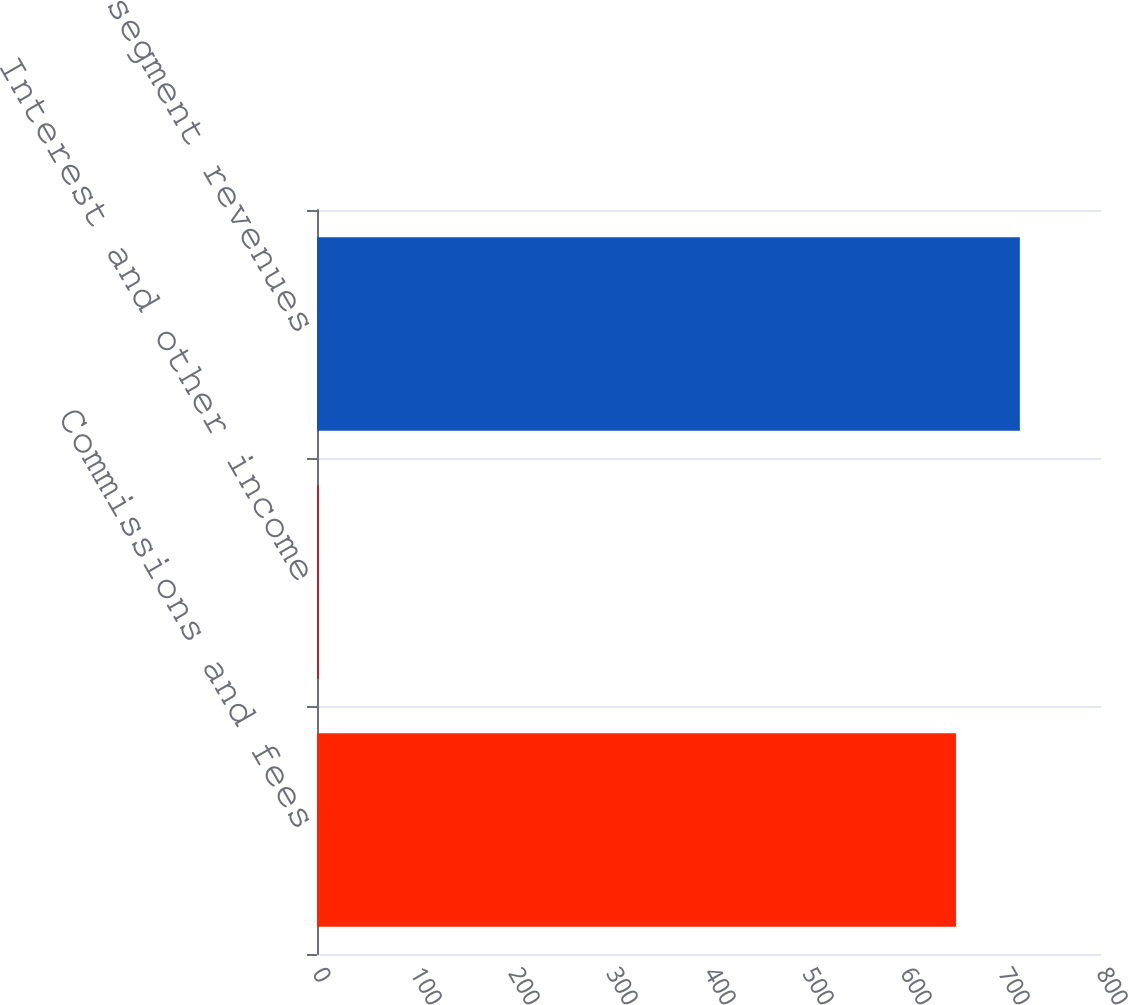Convert chart. <chart><loc_0><loc_0><loc_500><loc_500><bar_chart><fcel>Commissions and fees<fcel>Interest and other income<fcel>Total segment revenues<nl><fcel>652<fcel>2<fcel>717.2<nl></chart> 